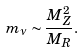<formula> <loc_0><loc_0><loc_500><loc_500>m _ { \nu } \sim \frac { M _ { Z } ^ { 2 } } { M _ { R } } .</formula> 